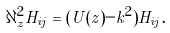<formula> <loc_0><loc_0><loc_500><loc_500>\partial _ { z } ^ { 2 } H _ { i j } = ( U ( z ) - k ^ { 2 } ) H _ { i j } .</formula> 